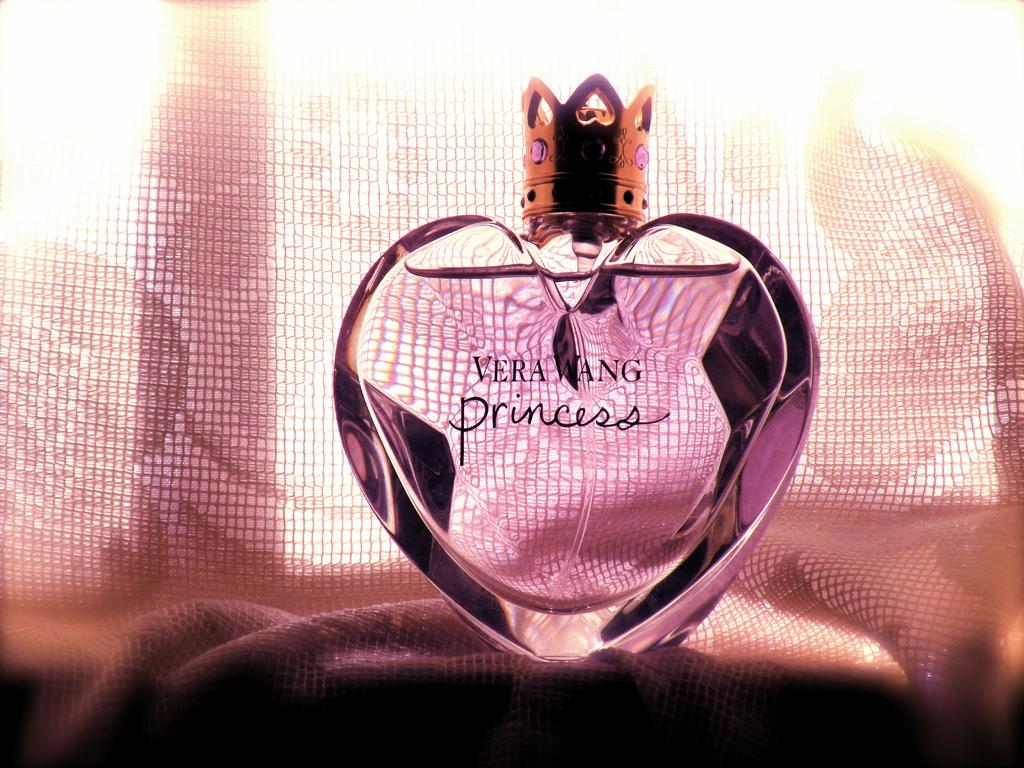<image>
Summarize the visual content of the image. Heart shaped Vera Wang Princess perfume on top of a surface. 